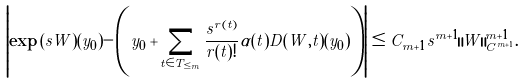<formula> <loc_0><loc_0><loc_500><loc_500>\left | \exp { ( s W ) } ( y _ { 0 } ) - \left ( y _ { 0 } + \sum _ { t \in T _ { \leq m } } \frac { s ^ { r ( t ) } } { r ( t ) ! } \alpha ( t ) D ( W , t ) \left ( y _ { 0 } \right ) \right ) \right | \leq C _ { m + 1 } s ^ { m + 1 } \| W \| _ { C ^ { m + 1 } } ^ { m + 1 } .</formula> 